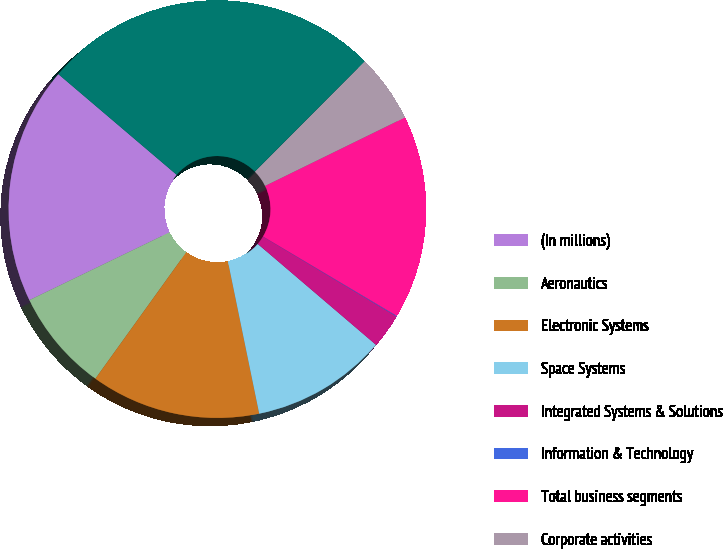Convert chart to OTSL. <chart><loc_0><loc_0><loc_500><loc_500><pie_chart><fcel>(In millions)<fcel>Aeronautics<fcel>Electronic Systems<fcel>Space Systems<fcel>Integrated Systems & Solutions<fcel>Information & Technology<fcel>Total business segments<fcel>Corporate activities<fcel>Corporate activities (d)<nl><fcel>18.39%<fcel>7.91%<fcel>13.15%<fcel>10.53%<fcel>2.67%<fcel>0.05%<fcel>15.77%<fcel>5.29%<fcel>26.25%<nl></chart> 